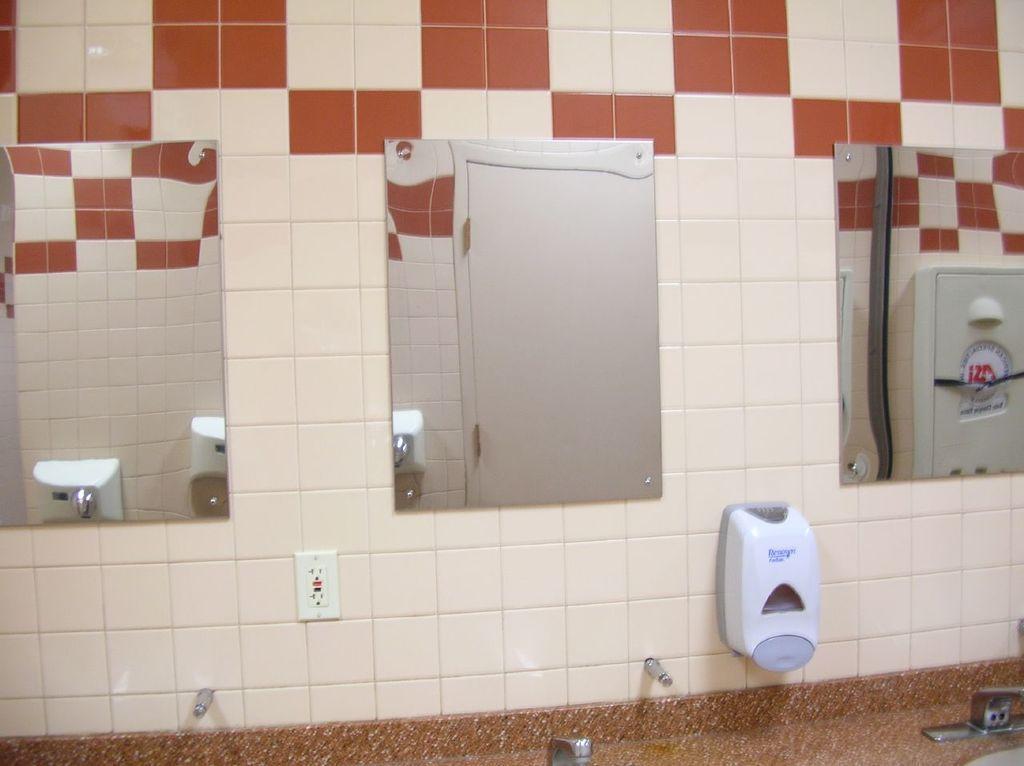In one or two sentences, can you explain what this image depicts? The image is taken in a washroom. In the center of the picture there are mirrors. At the bottom there are taps, sink, plug board and other objects. In this picture there are tiles to the wall. 